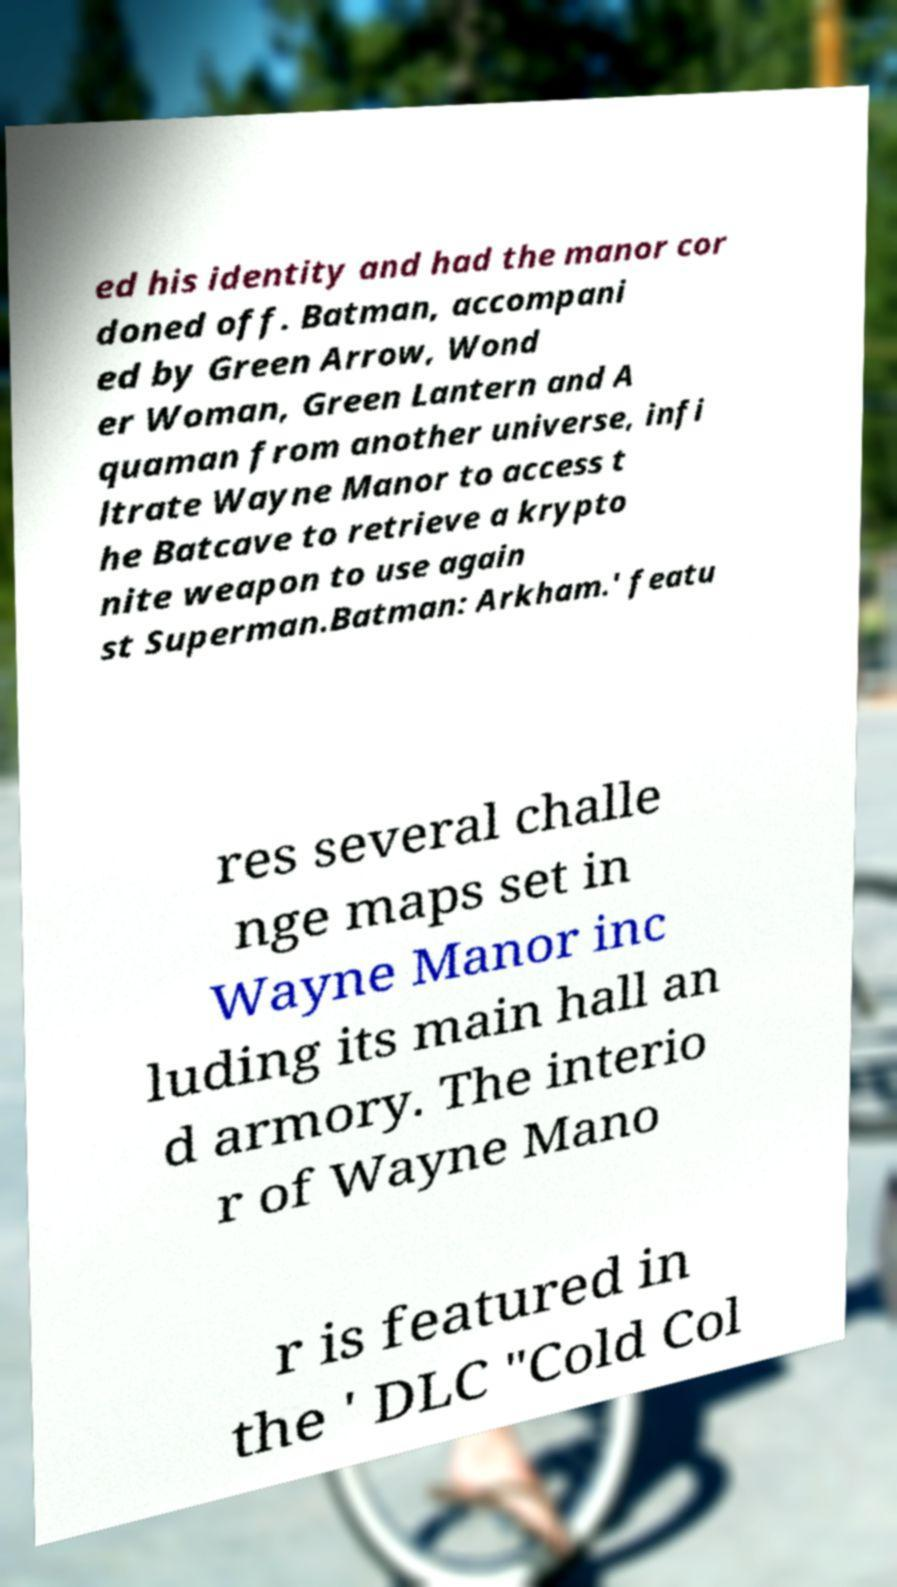There's text embedded in this image that I need extracted. Can you transcribe it verbatim? ed his identity and had the manor cor doned off. Batman, accompani ed by Green Arrow, Wond er Woman, Green Lantern and A quaman from another universe, infi ltrate Wayne Manor to access t he Batcave to retrieve a krypto nite weapon to use again st Superman.Batman: Arkham.' featu res several challe nge maps set in Wayne Manor inc luding its main hall an d armory. The interio r of Wayne Mano r is featured in the ' DLC "Cold Col 